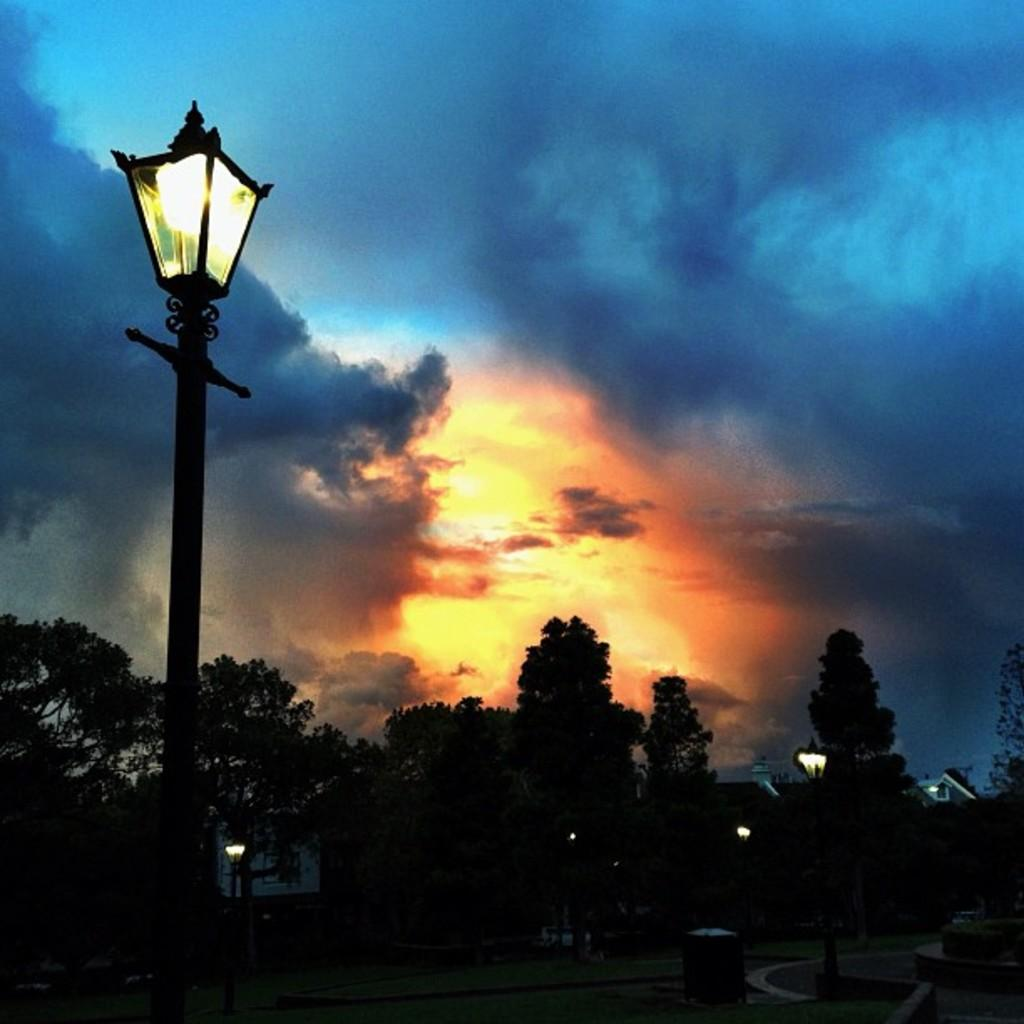What type of vegetation can be seen in the image? There are trees in the image. What structures are present in the image? There are poles in the image. What is visible in the background of the image? The sky is visible in the background of the image. How many arms are visible in the image? There are no arms present in the image. What type of loss is depicted in the image? There is no loss depicted in the image; it features trees and poles. 